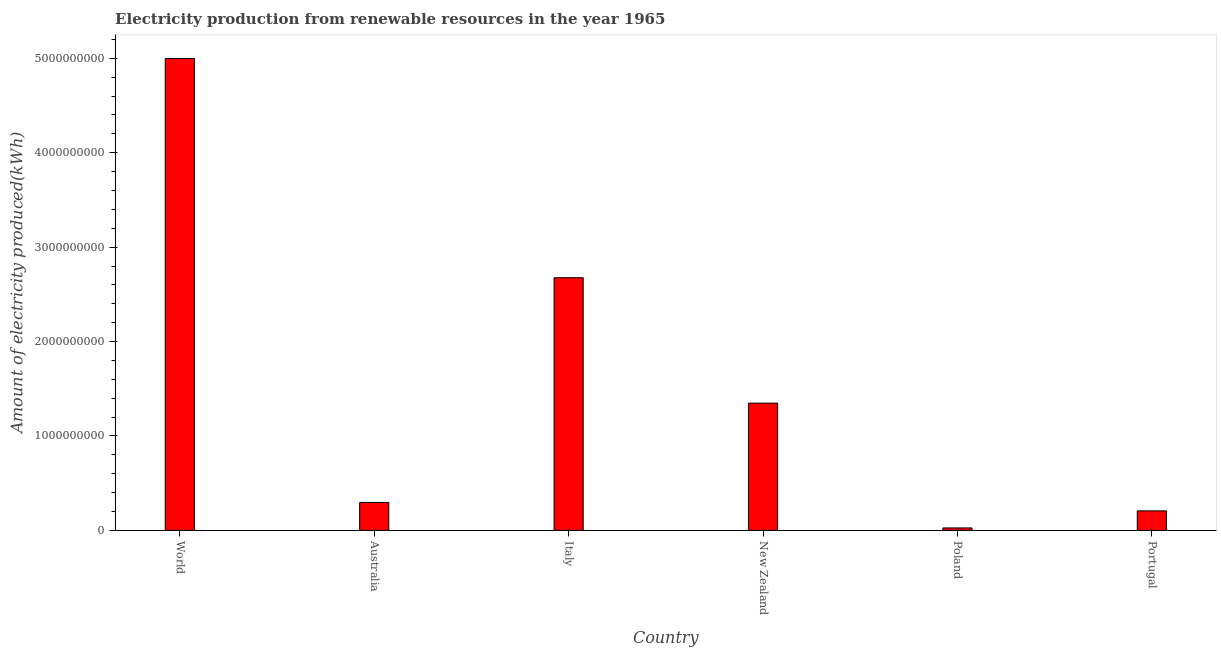Does the graph contain grids?
Provide a succinct answer. No. What is the title of the graph?
Your answer should be very brief. Electricity production from renewable resources in the year 1965. What is the label or title of the X-axis?
Offer a very short reply. Country. What is the label or title of the Y-axis?
Offer a terse response. Amount of electricity produced(kWh). What is the amount of electricity produced in World?
Your answer should be compact. 5.00e+09. Across all countries, what is the maximum amount of electricity produced?
Ensure brevity in your answer.  5.00e+09. Across all countries, what is the minimum amount of electricity produced?
Make the answer very short. 2.60e+07. In which country was the amount of electricity produced minimum?
Provide a succinct answer. Poland. What is the sum of the amount of electricity produced?
Provide a short and direct response. 9.55e+09. What is the difference between the amount of electricity produced in Australia and World?
Your answer should be compact. -4.70e+09. What is the average amount of electricity produced per country?
Ensure brevity in your answer.  1.59e+09. What is the median amount of electricity produced?
Provide a succinct answer. 8.22e+08. What is the ratio of the amount of electricity produced in Poland to that in World?
Give a very brief answer. 0.01. Is the amount of electricity produced in Australia less than that in World?
Offer a terse response. Yes. Is the difference between the amount of electricity produced in Australia and Poland greater than the difference between any two countries?
Offer a terse response. No. What is the difference between the highest and the second highest amount of electricity produced?
Provide a short and direct response. 2.32e+09. Is the sum of the amount of electricity produced in Poland and Portugal greater than the maximum amount of electricity produced across all countries?
Provide a succinct answer. No. What is the difference between the highest and the lowest amount of electricity produced?
Your response must be concise. 4.97e+09. In how many countries, is the amount of electricity produced greater than the average amount of electricity produced taken over all countries?
Offer a very short reply. 2. How many bars are there?
Your answer should be very brief. 6. Are all the bars in the graph horizontal?
Provide a succinct answer. No. What is the difference between two consecutive major ticks on the Y-axis?
Provide a succinct answer. 1.00e+09. What is the Amount of electricity produced(kWh) in World?
Keep it short and to the point. 5.00e+09. What is the Amount of electricity produced(kWh) of Australia?
Ensure brevity in your answer.  2.96e+08. What is the Amount of electricity produced(kWh) in Italy?
Your answer should be very brief. 2.68e+09. What is the Amount of electricity produced(kWh) in New Zealand?
Provide a succinct answer. 1.35e+09. What is the Amount of electricity produced(kWh) in Poland?
Make the answer very short. 2.60e+07. What is the Amount of electricity produced(kWh) in Portugal?
Give a very brief answer. 2.07e+08. What is the difference between the Amount of electricity produced(kWh) in World and Australia?
Provide a succinct answer. 4.70e+09. What is the difference between the Amount of electricity produced(kWh) in World and Italy?
Ensure brevity in your answer.  2.32e+09. What is the difference between the Amount of electricity produced(kWh) in World and New Zealand?
Your answer should be very brief. 3.65e+09. What is the difference between the Amount of electricity produced(kWh) in World and Poland?
Your answer should be compact. 4.97e+09. What is the difference between the Amount of electricity produced(kWh) in World and Portugal?
Provide a succinct answer. 4.79e+09. What is the difference between the Amount of electricity produced(kWh) in Australia and Italy?
Your response must be concise. -2.38e+09. What is the difference between the Amount of electricity produced(kWh) in Australia and New Zealand?
Make the answer very short. -1.05e+09. What is the difference between the Amount of electricity produced(kWh) in Australia and Poland?
Offer a terse response. 2.70e+08. What is the difference between the Amount of electricity produced(kWh) in Australia and Portugal?
Offer a very short reply. 8.90e+07. What is the difference between the Amount of electricity produced(kWh) in Italy and New Zealand?
Provide a short and direct response. 1.33e+09. What is the difference between the Amount of electricity produced(kWh) in Italy and Poland?
Give a very brief answer. 2.65e+09. What is the difference between the Amount of electricity produced(kWh) in Italy and Portugal?
Ensure brevity in your answer.  2.47e+09. What is the difference between the Amount of electricity produced(kWh) in New Zealand and Poland?
Provide a succinct answer. 1.32e+09. What is the difference between the Amount of electricity produced(kWh) in New Zealand and Portugal?
Your answer should be very brief. 1.14e+09. What is the difference between the Amount of electricity produced(kWh) in Poland and Portugal?
Offer a terse response. -1.81e+08. What is the ratio of the Amount of electricity produced(kWh) in World to that in Australia?
Your answer should be compact. 16.89. What is the ratio of the Amount of electricity produced(kWh) in World to that in Italy?
Offer a very short reply. 1.87. What is the ratio of the Amount of electricity produced(kWh) in World to that in New Zealand?
Make the answer very short. 3.71. What is the ratio of the Amount of electricity produced(kWh) in World to that in Poland?
Your answer should be compact. 192.23. What is the ratio of the Amount of electricity produced(kWh) in World to that in Portugal?
Your answer should be very brief. 24.14. What is the ratio of the Amount of electricity produced(kWh) in Australia to that in Italy?
Make the answer very short. 0.11. What is the ratio of the Amount of electricity produced(kWh) in Australia to that in New Zealand?
Your answer should be very brief. 0.22. What is the ratio of the Amount of electricity produced(kWh) in Australia to that in Poland?
Give a very brief answer. 11.38. What is the ratio of the Amount of electricity produced(kWh) in Australia to that in Portugal?
Your answer should be very brief. 1.43. What is the ratio of the Amount of electricity produced(kWh) in Italy to that in New Zealand?
Offer a terse response. 1.99. What is the ratio of the Amount of electricity produced(kWh) in Italy to that in Poland?
Your answer should be very brief. 102.92. What is the ratio of the Amount of electricity produced(kWh) in Italy to that in Portugal?
Offer a very short reply. 12.93. What is the ratio of the Amount of electricity produced(kWh) in New Zealand to that in Poland?
Your response must be concise. 51.85. What is the ratio of the Amount of electricity produced(kWh) in New Zealand to that in Portugal?
Make the answer very short. 6.51. What is the ratio of the Amount of electricity produced(kWh) in Poland to that in Portugal?
Keep it short and to the point. 0.13. 